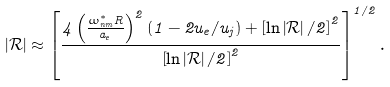Convert formula to latex. <formula><loc_0><loc_0><loc_500><loc_500>\left | \mathcal { R } \right | \approx \left [ \frac { 4 \left ( \frac { \omega _ { n m } ^ { \ast } R } { a _ { e } } \right ) ^ { 2 } \left ( 1 - 2 u _ { e } / u _ { j } \right ) + \left [ \ln \left | \mathcal { R } \right | / 2 \right ] ^ { 2 } } { \left [ \ln \left | \mathcal { R } \right | / 2 \right ] ^ { 2 } } \right ] ^ { 1 / 2 } .</formula> 